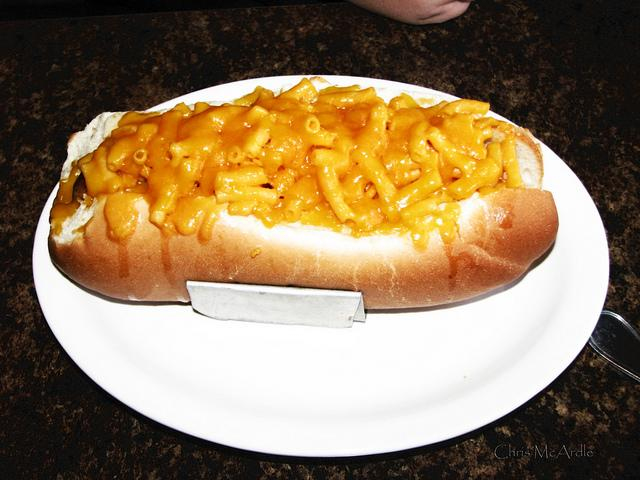What type of food is on top of the bread? Please explain your reasoning. noodles. The food on top is macaroni and cheese judging by the appearance and answer a is a component of macaroni and cheese. 